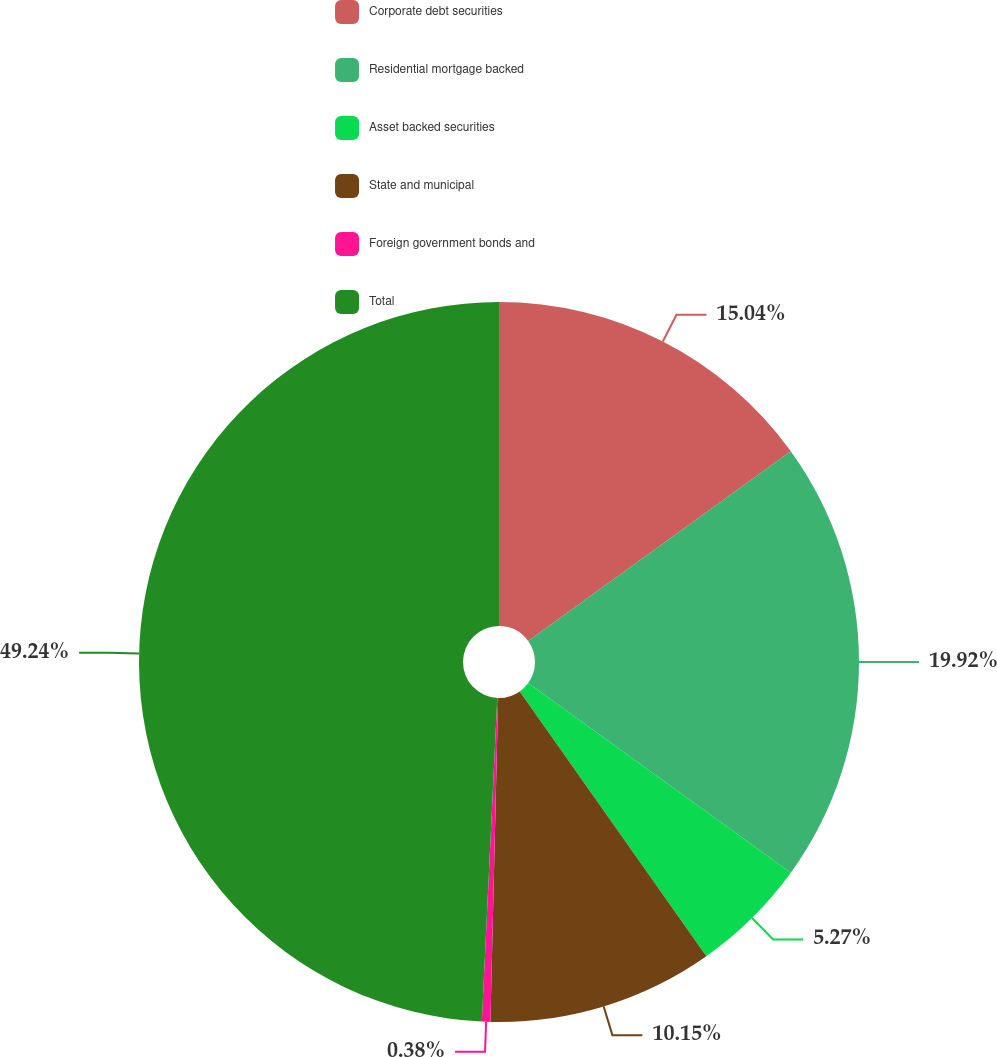<chart> <loc_0><loc_0><loc_500><loc_500><pie_chart><fcel>Corporate debt securities<fcel>Residential mortgage backed<fcel>Asset backed securities<fcel>State and municipal<fcel>Foreign government bonds and<fcel>Total<nl><fcel>15.04%<fcel>19.92%<fcel>5.27%<fcel>10.15%<fcel>0.38%<fcel>49.24%<nl></chart> 